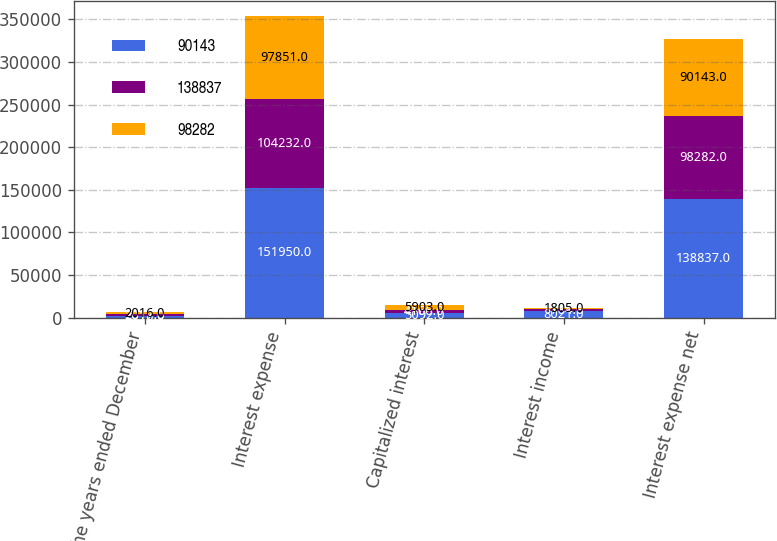Convert chart to OTSL. <chart><loc_0><loc_0><loc_500><loc_500><stacked_bar_chart><ecel><fcel>For the years ended December<fcel>Interest expense<fcel>Capitalized interest<fcel>Interest income<fcel>Interest expense net<nl><fcel>90143<fcel>2018<fcel>151950<fcel>5092<fcel>8021<fcel>138837<nl><fcel>138837<fcel>2017<fcel>104232<fcel>4166<fcel>1784<fcel>98282<nl><fcel>98282<fcel>2016<fcel>97851<fcel>5903<fcel>1805<fcel>90143<nl></chart> 